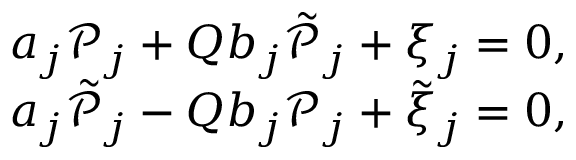<formula> <loc_0><loc_0><loc_500><loc_500>\begin{array} { r } { a _ { j } \mathcal { P } _ { j } + Q b _ { j } \tilde { \mathcal { P } } _ { j } + \xi _ { j } = 0 , } \\ { a _ { j } \tilde { \mathcal { P } } _ { j } - Q b _ { j } \mathcal { P } _ { j } + \tilde { \xi } _ { j } = 0 , } \end{array}</formula> 